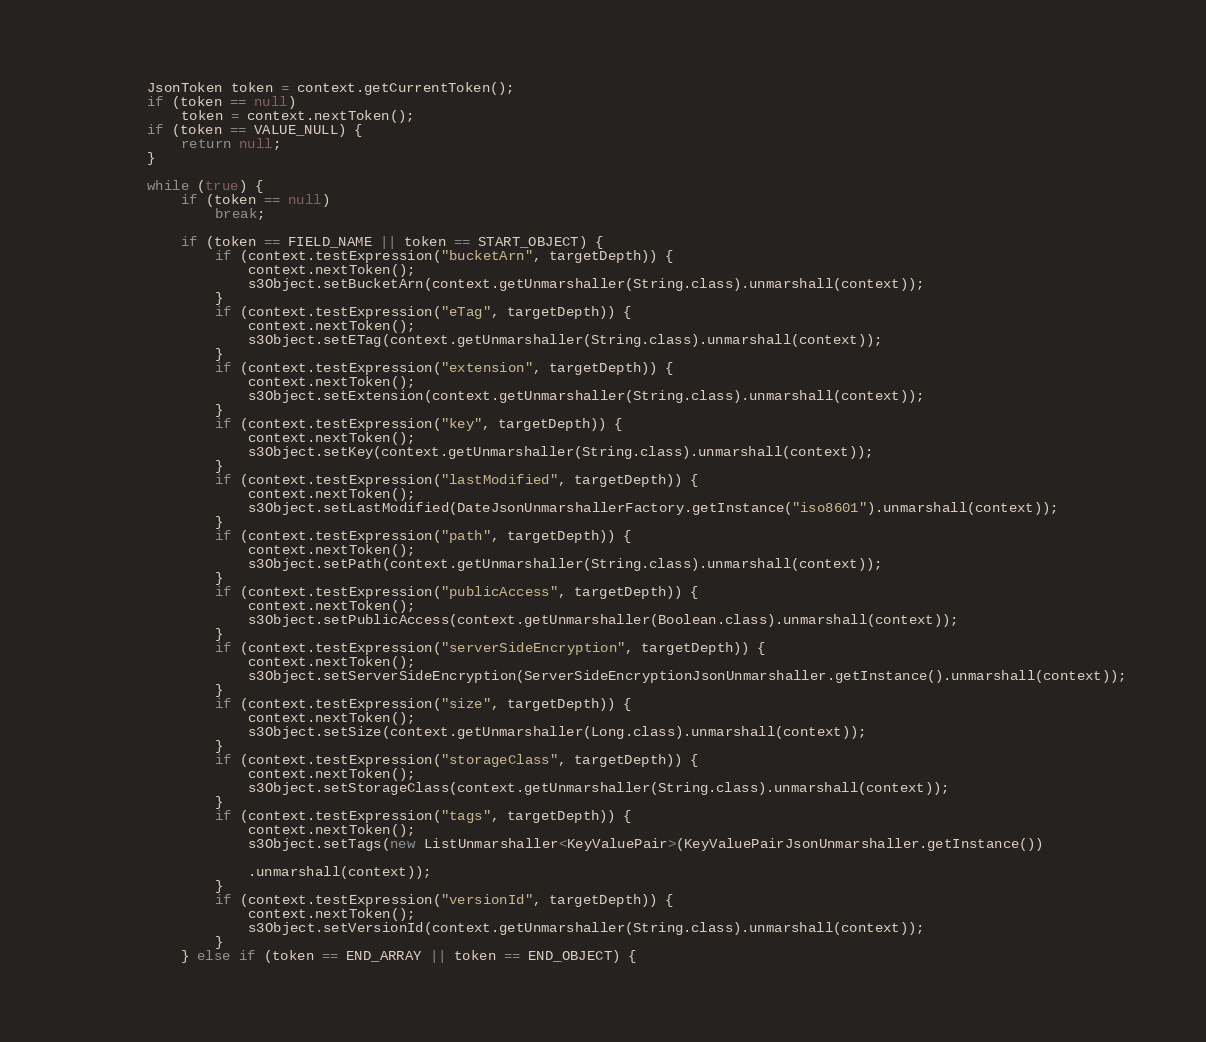<code> <loc_0><loc_0><loc_500><loc_500><_Java_>
        JsonToken token = context.getCurrentToken();
        if (token == null)
            token = context.nextToken();
        if (token == VALUE_NULL) {
            return null;
        }

        while (true) {
            if (token == null)
                break;

            if (token == FIELD_NAME || token == START_OBJECT) {
                if (context.testExpression("bucketArn", targetDepth)) {
                    context.nextToken();
                    s3Object.setBucketArn(context.getUnmarshaller(String.class).unmarshall(context));
                }
                if (context.testExpression("eTag", targetDepth)) {
                    context.nextToken();
                    s3Object.setETag(context.getUnmarshaller(String.class).unmarshall(context));
                }
                if (context.testExpression("extension", targetDepth)) {
                    context.nextToken();
                    s3Object.setExtension(context.getUnmarshaller(String.class).unmarshall(context));
                }
                if (context.testExpression("key", targetDepth)) {
                    context.nextToken();
                    s3Object.setKey(context.getUnmarshaller(String.class).unmarshall(context));
                }
                if (context.testExpression("lastModified", targetDepth)) {
                    context.nextToken();
                    s3Object.setLastModified(DateJsonUnmarshallerFactory.getInstance("iso8601").unmarshall(context));
                }
                if (context.testExpression("path", targetDepth)) {
                    context.nextToken();
                    s3Object.setPath(context.getUnmarshaller(String.class).unmarshall(context));
                }
                if (context.testExpression("publicAccess", targetDepth)) {
                    context.nextToken();
                    s3Object.setPublicAccess(context.getUnmarshaller(Boolean.class).unmarshall(context));
                }
                if (context.testExpression("serverSideEncryption", targetDepth)) {
                    context.nextToken();
                    s3Object.setServerSideEncryption(ServerSideEncryptionJsonUnmarshaller.getInstance().unmarshall(context));
                }
                if (context.testExpression("size", targetDepth)) {
                    context.nextToken();
                    s3Object.setSize(context.getUnmarshaller(Long.class).unmarshall(context));
                }
                if (context.testExpression("storageClass", targetDepth)) {
                    context.nextToken();
                    s3Object.setStorageClass(context.getUnmarshaller(String.class).unmarshall(context));
                }
                if (context.testExpression("tags", targetDepth)) {
                    context.nextToken();
                    s3Object.setTags(new ListUnmarshaller<KeyValuePair>(KeyValuePairJsonUnmarshaller.getInstance())

                    .unmarshall(context));
                }
                if (context.testExpression("versionId", targetDepth)) {
                    context.nextToken();
                    s3Object.setVersionId(context.getUnmarshaller(String.class).unmarshall(context));
                }
            } else if (token == END_ARRAY || token == END_OBJECT) {</code> 